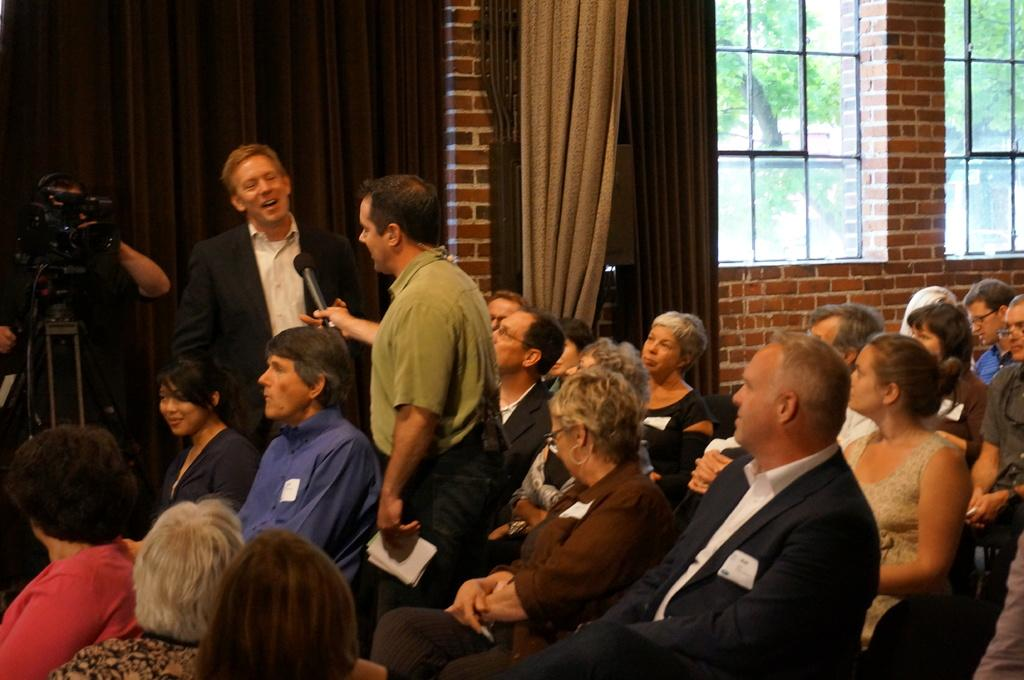What are the people in the room doing? There are people sitting and standing in the room. Can you describe the person holding a microphone? One person is holding a microphone, which might suggest they are giving a speech or presentation. What is the person wearing a suit doing? Another person is wearing a suit, but we cannot determine their specific actions from the image. What equipment is present in the room? There is a camera in the room. What type of window treatment is present in the room? There are curtains in the room. Can you describe the windows in the room? There are windows in the room. Where is the father sitting in the room? There is no mention of a father in the image, so we cannot determine where they might be sitting. Can you see any blades in the image? There are no blades visible in the image. 